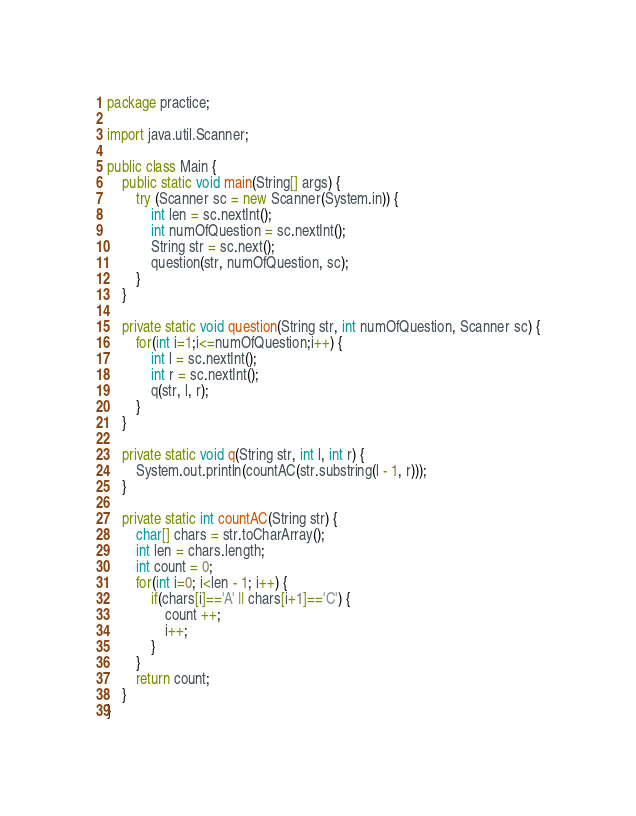Convert code to text. <code><loc_0><loc_0><loc_500><loc_500><_Java_>package practice;

import java.util.Scanner;

public class Main {
	public static void main(String[] args) {
		try (Scanner sc = new Scanner(System.in)) {
			int len = sc.nextInt();
			int numOfQuestion = sc.nextInt();
			String str = sc.next();
			question(str, numOfQuestion, sc);
		}
	}
	
	private static void question(String str, int numOfQuestion, Scanner sc) {
		for(int i=1;i<=numOfQuestion;i++) {
			int l = sc.nextInt();
			int r = sc.nextInt();
			q(str, l, r);
		}
	}
	
	private static void q(String str, int l, int r) {
		System.out.println(countAC(str.substring(l - 1, r)));
	}
	
	private static int countAC(String str) {
		char[] chars = str.toCharArray();
		int len = chars.length;
		int count = 0;
		for(int i=0; i<len - 1; i++) {
			if(chars[i]=='A' || chars[i+1]=='C') {
				count ++;
				i++;
			}
		}
		return count;
	}
}
</code> 